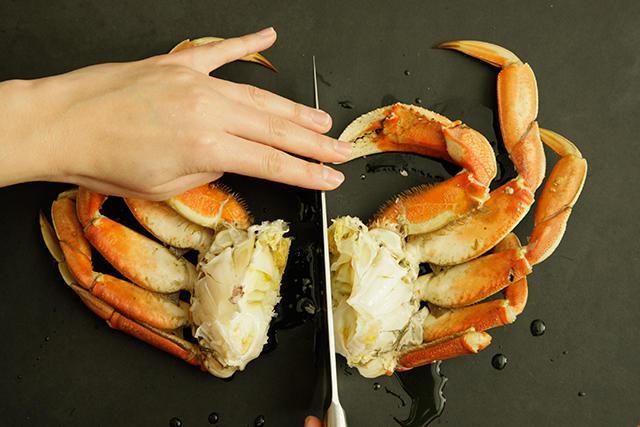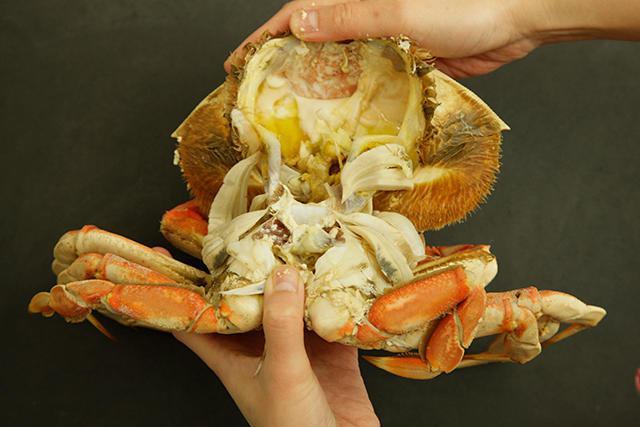The first image is the image on the left, the second image is the image on the right. Assess this claim about the two images: "In the image on the right, a person is pulling apart the crab to expose its meat.". Correct or not? Answer yes or no. Yes. The first image is the image on the left, the second image is the image on the right. Considering the images on both sides, is "Atleast one image of a crab split down the middle." valid? Answer yes or no. Yes. 